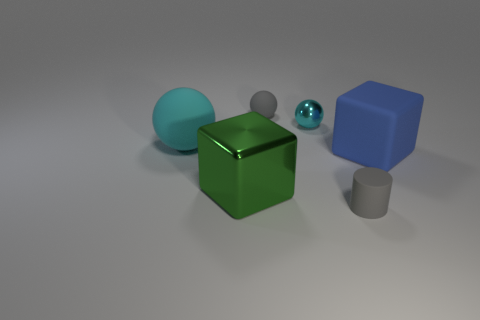What material is the small thing that is the same color as the large rubber sphere?
Offer a very short reply. Metal. Is the number of spheres to the right of the large green shiny thing greater than the number of small shiny spheres?
Make the answer very short. Yes. How many rubber things have the same color as the metallic ball?
Your response must be concise. 1. What number of other objects are the same color as the matte cylinder?
Your answer should be very brief. 1. Is the number of red matte cubes greater than the number of large blue rubber cubes?
Make the answer very short. No. What is the green thing made of?
Keep it short and to the point. Metal. Does the rubber object left of the green object have the same size as the tiny metallic object?
Offer a terse response. No. There is a metal object that is in front of the blue matte object; what size is it?
Ensure brevity in your answer.  Large. What number of green things are there?
Make the answer very short. 1. Is the metallic ball the same color as the large rubber ball?
Offer a terse response. Yes. 